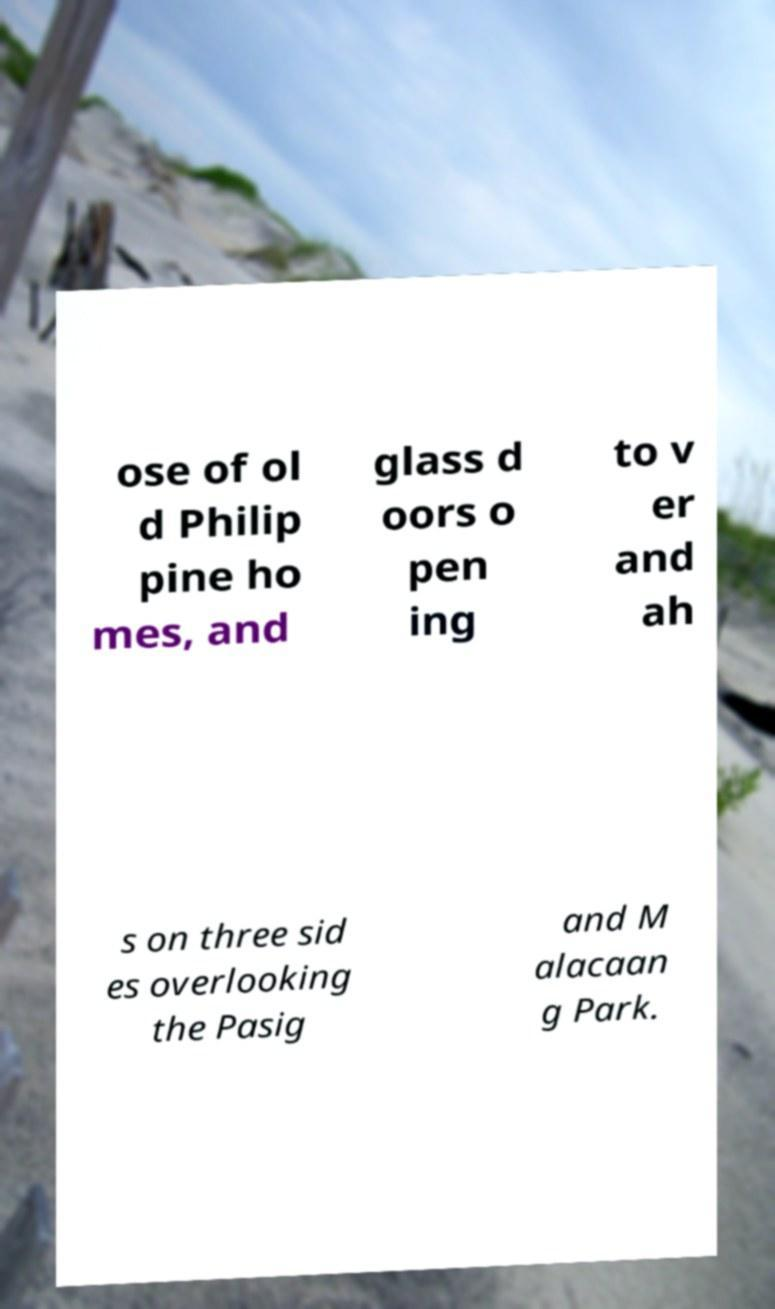Can you accurately transcribe the text from the provided image for me? ose of ol d Philip pine ho mes, and glass d oors o pen ing to v er and ah s on three sid es overlooking the Pasig and M alacaan g Park. 